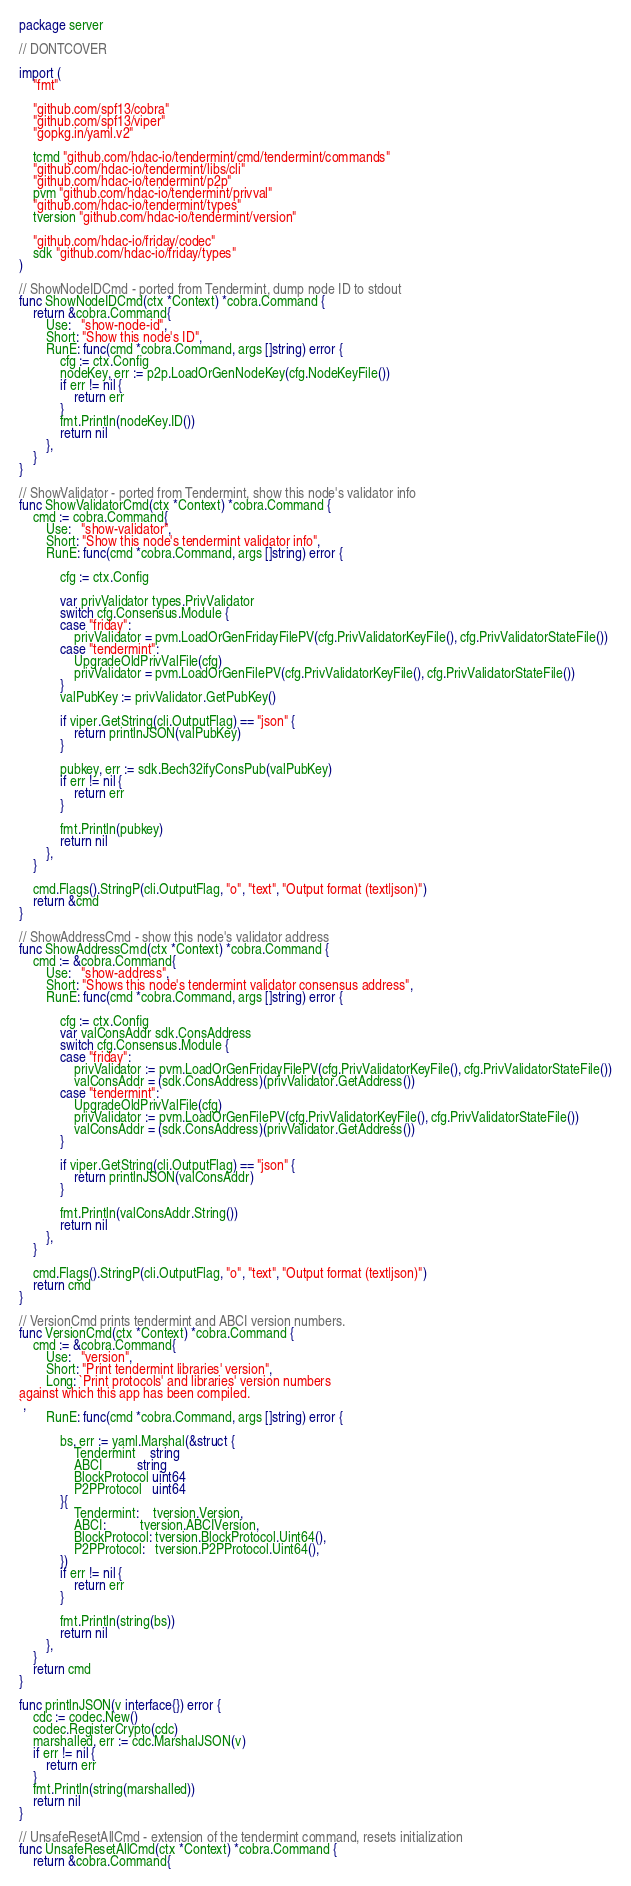<code> <loc_0><loc_0><loc_500><loc_500><_Go_>package server

// DONTCOVER

import (
	"fmt"

	"github.com/spf13/cobra"
	"github.com/spf13/viper"
	"gopkg.in/yaml.v2"

	tcmd "github.com/hdac-io/tendermint/cmd/tendermint/commands"
	"github.com/hdac-io/tendermint/libs/cli"
	"github.com/hdac-io/tendermint/p2p"
	pvm "github.com/hdac-io/tendermint/privval"
	"github.com/hdac-io/tendermint/types"
	tversion "github.com/hdac-io/tendermint/version"

	"github.com/hdac-io/friday/codec"
	sdk "github.com/hdac-io/friday/types"
)

// ShowNodeIDCmd - ported from Tendermint, dump node ID to stdout
func ShowNodeIDCmd(ctx *Context) *cobra.Command {
	return &cobra.Command{
		Use:   "show-node-id",
		Short: "Show this node's ID",
		RunE: func(cmd *cobra.Command, args []string) error {
			cfg := ctx.Config
			nodeKey, err := p2p.LoadOrGenNodeKey(cfg.NodeKeyFile())
			if err != nil {
				return err
			}
			fmt.Println(nodeKey.ID())
			return nil
		},
	}
}

// ShowValidator - ported from Tendermint, show this node's validator info
func ShowValidatorCmd(ctx *Context) *cobra.Command {
	cmd := cobra.Command{
		Use:   "show-validator",
		Short: "Show this node's tendermint validator info",
		RunE: func(cmd *cobra.Command, args []string) error {

			cfg := ctx.Config

			var privValidator types.PrivValidator
			switch cfg.Consensus.Module {
			case "friday":
				privValidator = pvm.LoadOrGenFridayFilePV(cfg.PrivValidatorKeyFile(), cfg.PrivValidatorStateFile())
			case "tendermint":
				UpgradeOldPrivValFile(cfg)
				privValidator = pvm.LoadOrGenFilePV(cfg.PrivValidatorKeyFile(), cfg.PrivValidatorStateFile())
			}
			valPubKey := privValidator.GetPubKey()

			if viper.GetString(cli.OutputFlag) == "json" {
				return printlnJSON(valPubKey)
			}

			pubkey, err := sdk.Bech32ifyConsPub(valPubKey)
			if err != nil {
				return err
			}

			fmt.Println(pubkey)
			return nil
		},
	}

	cmd.Flags().StringP(cli.OutputFlag, "o", "text", "Output format (text|json)")
	return &cmd
}

// ShowAddressCmd - show this node's validator address
func ShowAddressCmd(ctx *Context) *cobra.Command {
	cmd := &cobra.Command{
		Use:   "show-address",
		Short: "Shows this node's tendermint validator consensus address",
		RunE: func(cmd *cobra.Command, args []string) error {

			cfg := ctx.Config
			var valConsAddr sdk.ConsAddress
			switch cfg.Consensus.Module {
			case "friday":
				privValidator := pvm.LoadOrGenFridayFilePV(cfg.PrivValidatorKeyFile(), cfg.PrivValidatorStateFile())
				valConsAddr = (sdk.ConsAddress)(privValidator.GetAddress())
			case "tendermint":
				UpgradeOldPrivValFile(cfg)
				privValidator := pvm.LoadOrGenFilePV(cfg.PrivValidatorKeyFile(), cfg.PrivValidatorStateFile())
				valConsAddr = (sdk.ConsAddress)(privValidator.GetAddress())
			}

			if viper.GetString(cli.OutputFlag) == "json" {
				return printlnJSON(valConsAddr)
			}

			fmt.Println(valConsAddr.String())
			return nil
		},
	}

	cmd.Flags().StringP(cli.OutputFlag, "o", "text", "Output format (text|json)")
	return cmd
}

// VersionCmd prints tendermint and ABCI version numbers.
func VersionCmd(ctx *Context) *cobra.Command {
	cmd := &cobra.Command{
		Use:   "version",
		Short: "Print tendermint libraries' version",
		Long: `Print protocols' and libraries' version numbers
against which this app has been compiled.
`,
		RunE: func(cmd *cobra.Command, args []string) error {

			bs, err := yaml.Marshal(&struct {
				Tendermint    string
				ABCI          string
				BlockProtocol uint64
				P2PProtocol   uint64
			}{
				Tendermint:    tversion.Version,
				ABCI:          tversion.ABCIVersion,
				BlockProtocol: tversion.BlockProtocol.Uint64(),
				P2PProtocol:   tversion.P2PProtocol.Uint64(),
			})
			if err != nil {
				return err
			}

			fmt.Println(string(bs))
			return nil
		},
	}
	return cmd
}

func printlnJSON(v interface{}) error {
	cdc := codec.New()
	codec.RegisterCrypto(cdc)
	marshalled, err := cdc.MarshalJSON(v)
	if err != nil {
		return err
	}
	fmt.Println(string(marshalled))
	return nil
}

// UnsafeResetAllCmd - extension of the tendermint command, resets initialization
func UnsafeResetAllCmd(ctx *Context) *cobra.Command {
	return &cobra.Command{</code> 